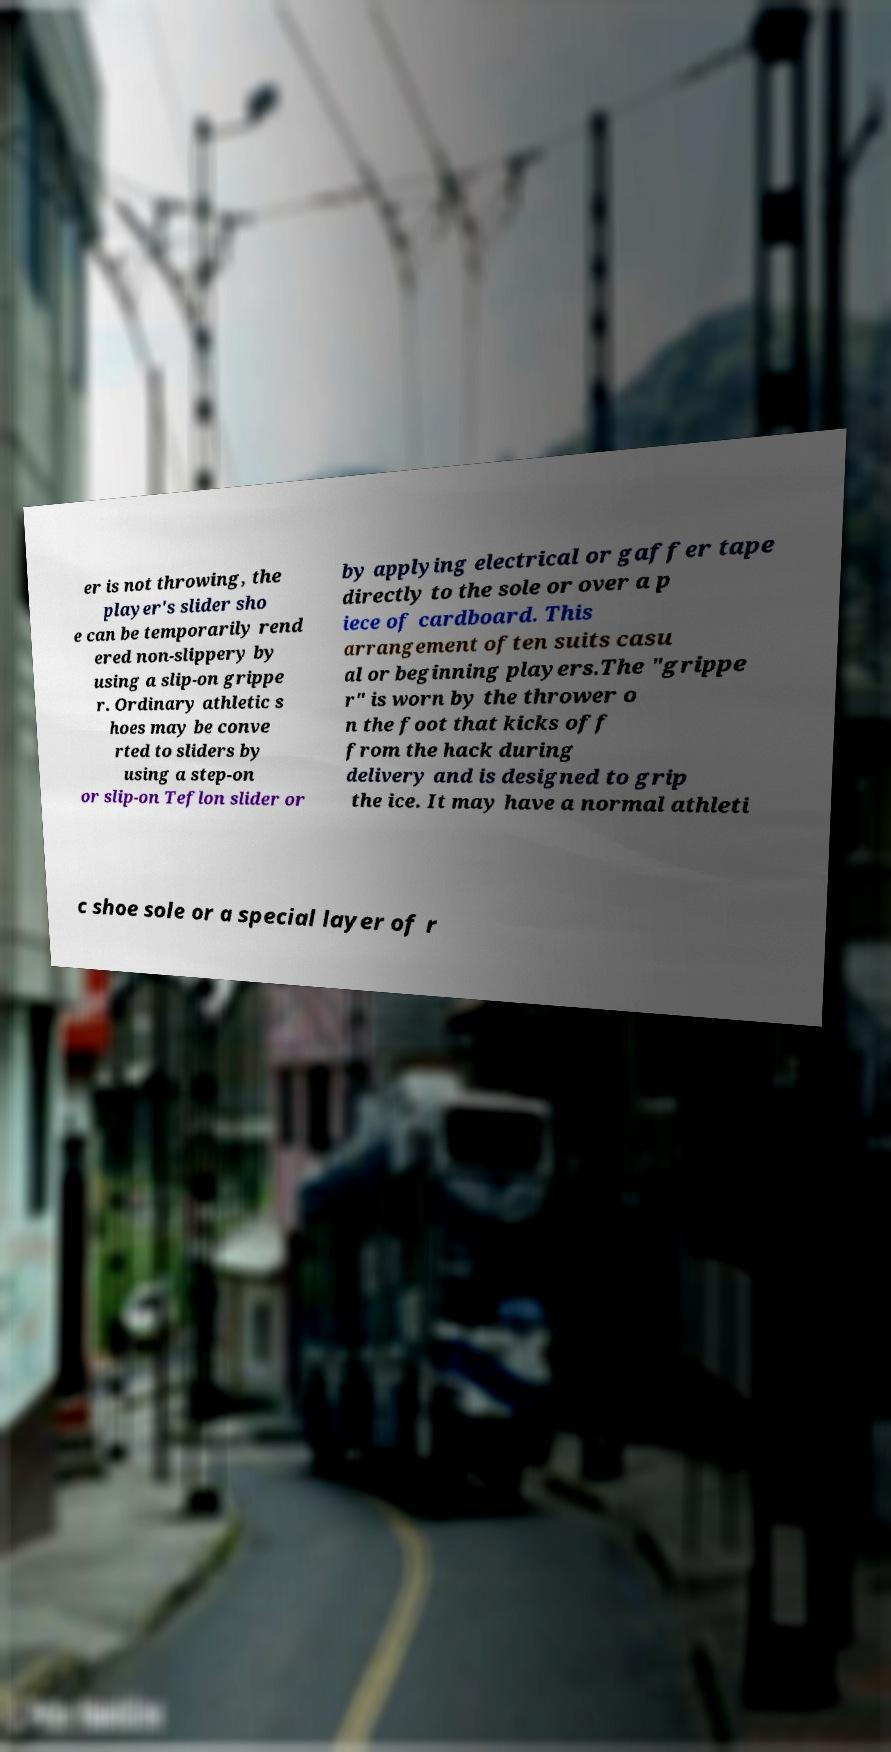Could you assist in decoding the text presented in this image and type it out clearly? er is not throwing, the player's slider sho e can be temporarily rend ered non-slippery by using a slip-on grippe r. Ordinary athletic s hoes may be conve rted to sliders by using a step-on or slip-on Teflon slider or by applying electrical or gaffer tape directly to the sole or over a p iece of cardboard. This arrangement often suits casu al or beginning players.The "grippe r" is worn by the thrower o n the foot that kicks off from the hack during delivery and is designed to grip the ice. It may have a normal athleti c shoe sole or a special layer of r 